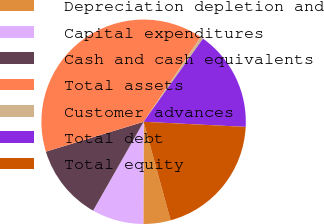Convert chart. <chart><loc_0><loc_0><loc_500><loc_500><pie_chart><fcel>Depreciation depletion and<fcel>Capital expenditures<fcel>Cash and cash equivalents<fcel>Total assets<fcel>Customer advances<fcel>Total debt<fcel>Total equity<nl><fcel>4.31%<fcel>8.18%<fcel>12.05%<fcel>39.15%<fcel>0.44%<fcel>15.92%<fcel>19.94%<nl></chart> 